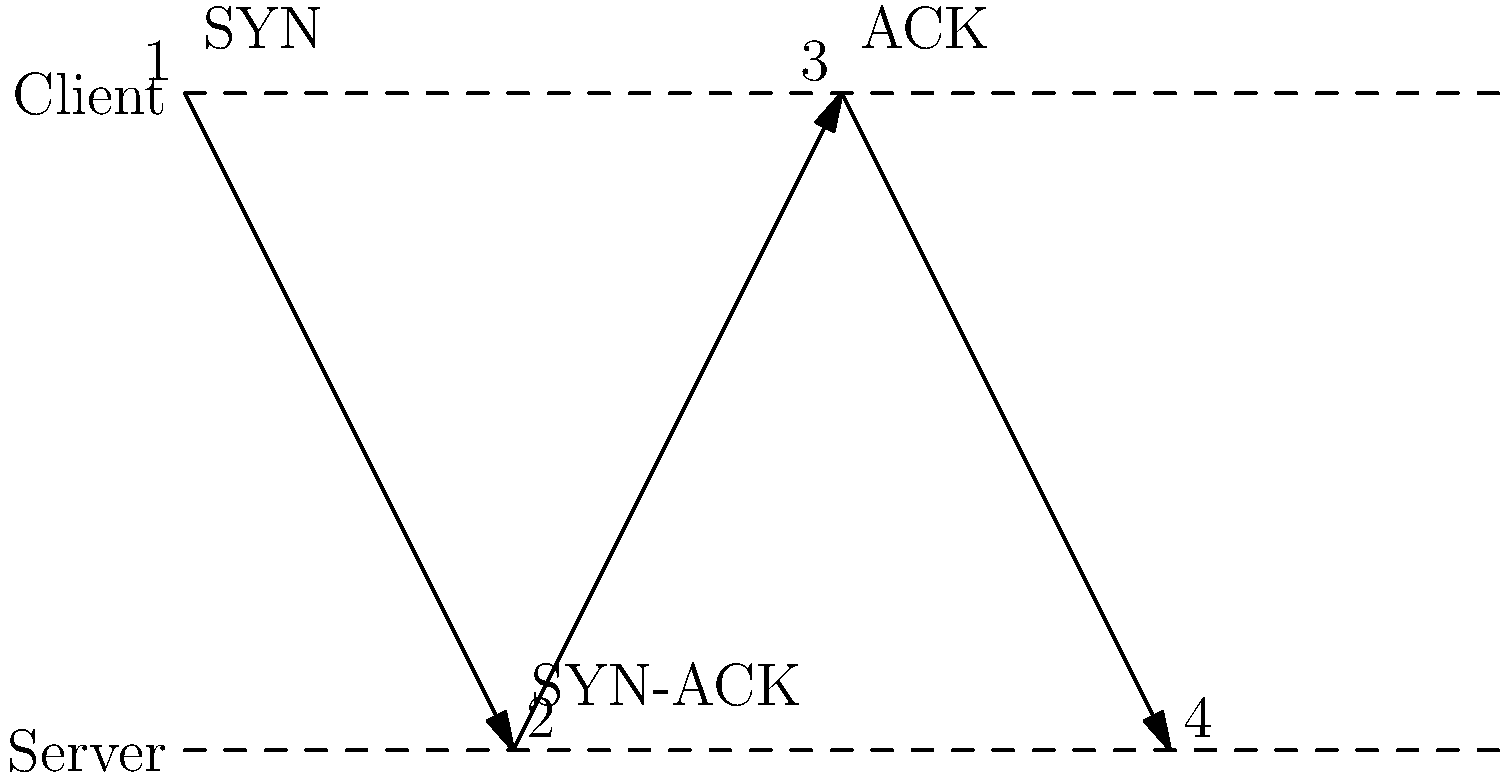In the TCP handshake process shown in the sequence diagram, what is the purpose of the SYN-ACK message sent by the server in step 2? The TCP handshake process, also known as the three-way handshake, establishes a reliable connection between a client and a server. Let's break down the steps:

1. The client initiates the connection by sending a SYN (synchronize) packet to the server. This packet contains an initial sequence number (ISN) for the client.

2. Upon receiving the SYN packet, the server responds with a SYN-ACK (synchronize-acknowledge) packet. This packet serves two purposes:
   a) It acknowledges the client's SYN packet by incrementing the client's sequence number by 1.
   b) It includes the server's own SYN packet with its initial sequence number.

3. The client then sends an ACK (acknowledge) packet back to the server, confirming the receipt of the server's SYN packet.

The SYN-ACK message in step 2 is crucial because:
- It confirms to the client that the server has received its initial SYN packet.
- It informs the client that the server is ready to establish a connection.
- It provides the server's own synchronization information (sequence number) to the client.

This step ensures that both parties have acknowledged each other's initial sequence numbers, allowing for reliable, ordered data transmission once the connection is established.
Answer: Acknowledge client's SYN and send server's SYN 